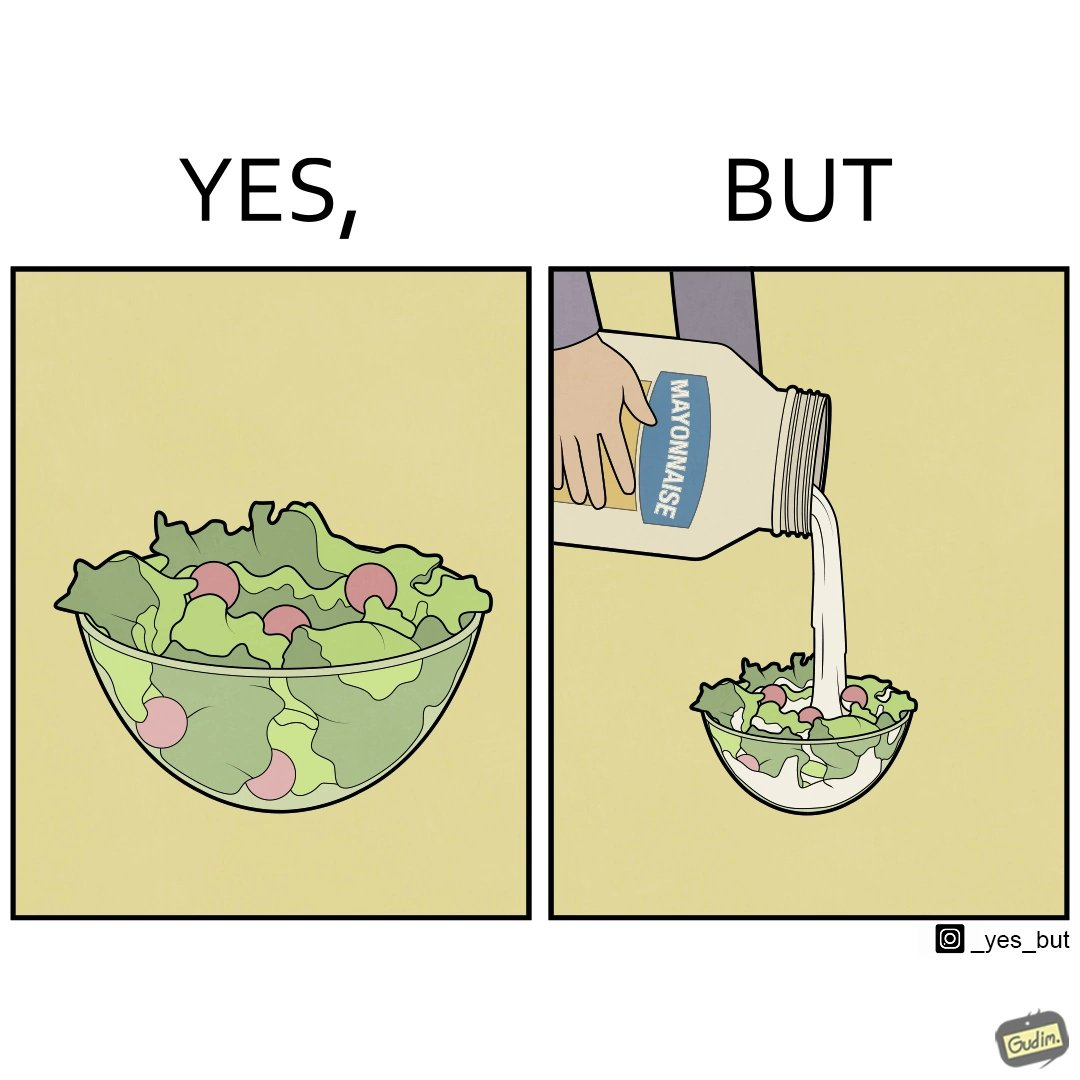What is the satirical meaning behind this image? The image is ironical, as salad in a bowl by itself is very healthy. However, when people have it with Mayonnaise sauce to improve the taste, it is not healthy anymore, and defeats the point of having nutrient-rich salad altogether. 